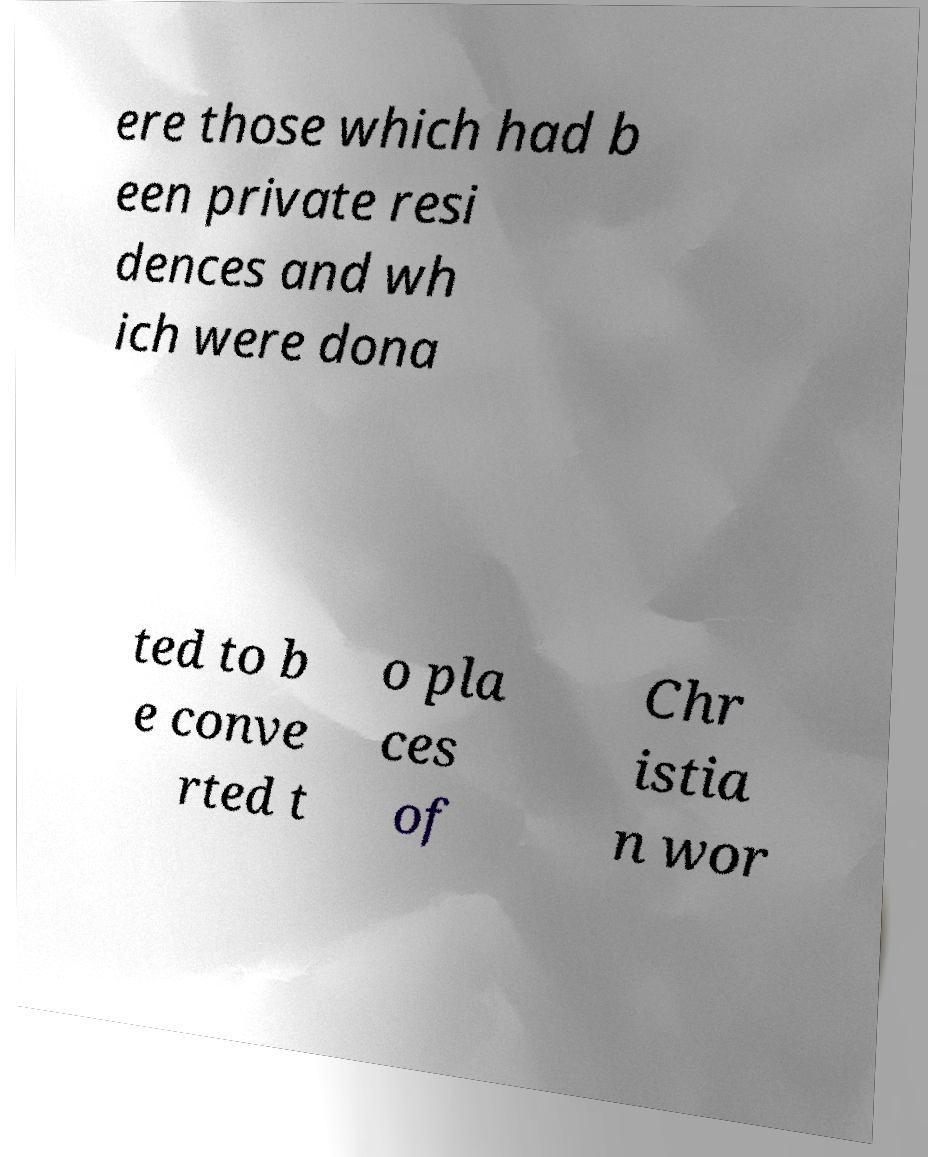What messages or text are displayed in this image? I need them in a readable, typed format. ere those which had b een private resi dences and wh ich were dona ted to b e conve rted t o pla ces of Chr istia n wor 